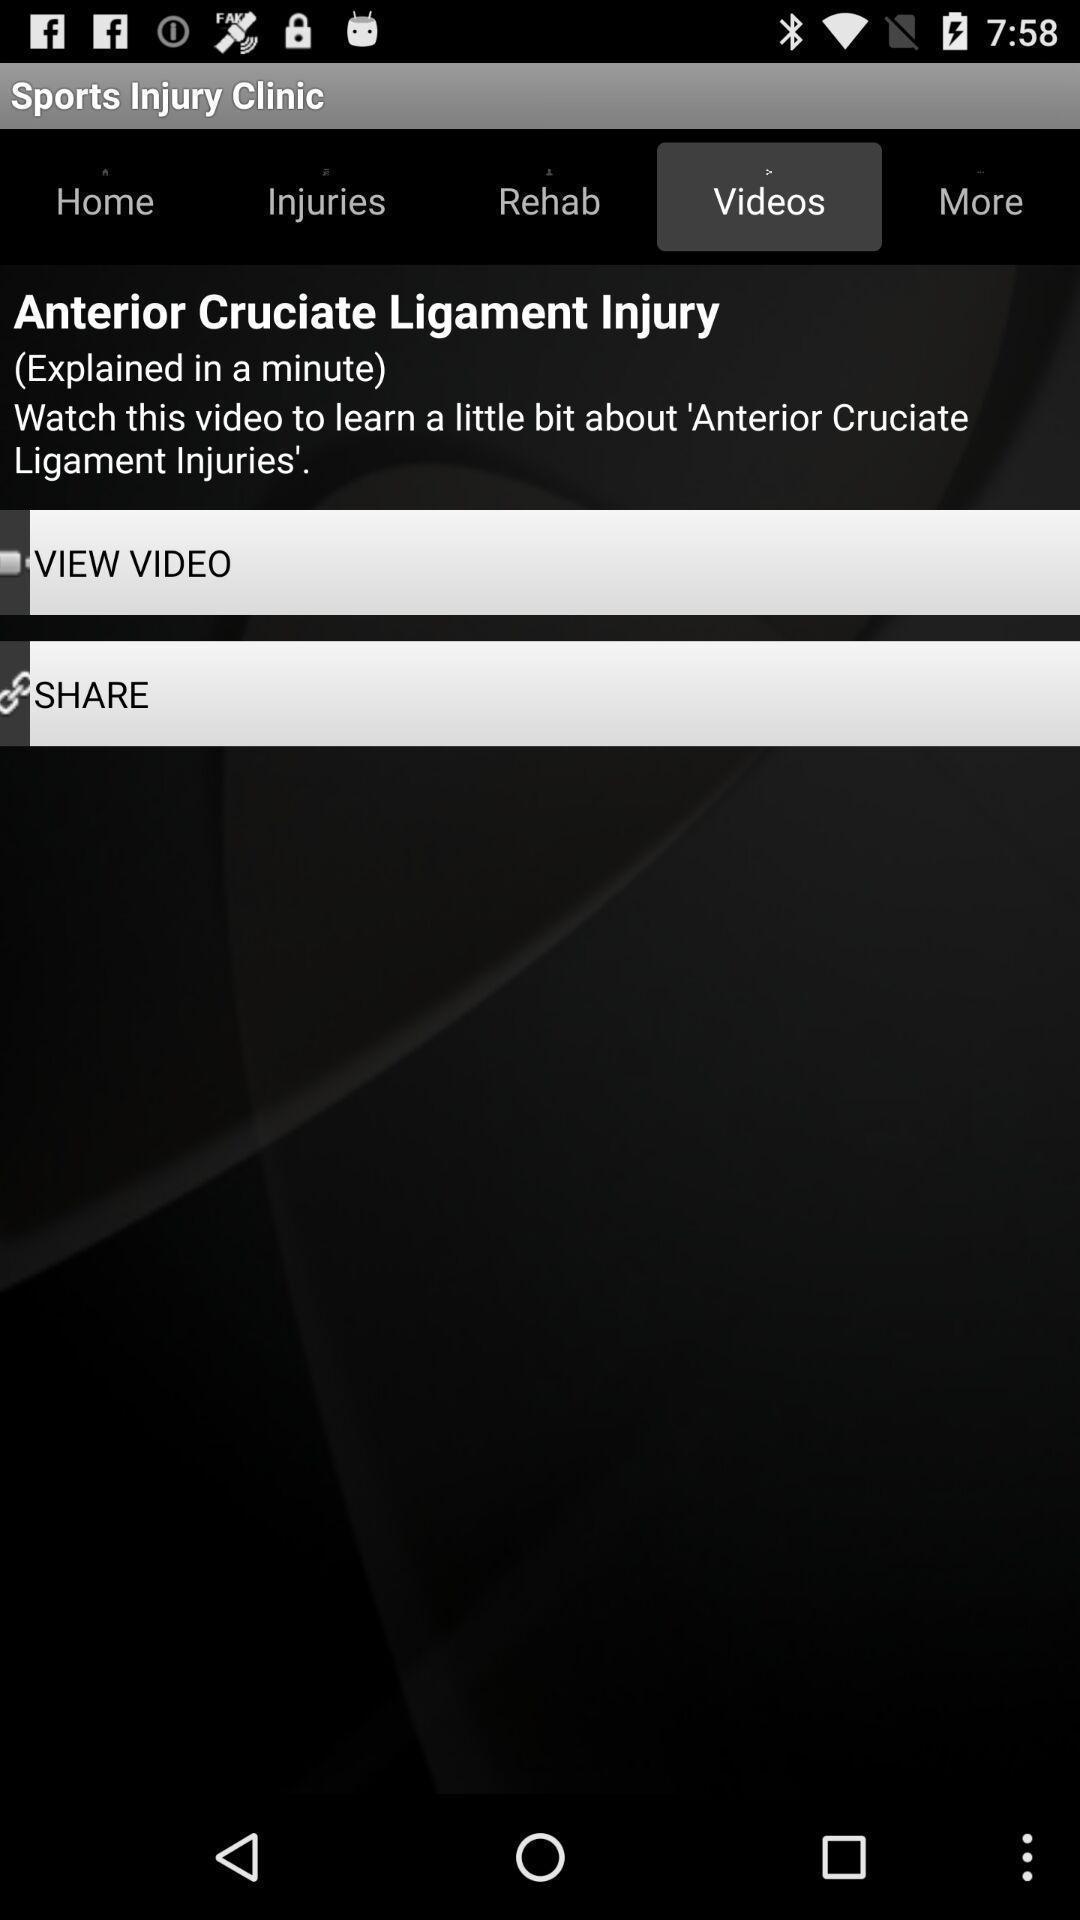Please provide a description for this image. Video uploading page in medical app. 